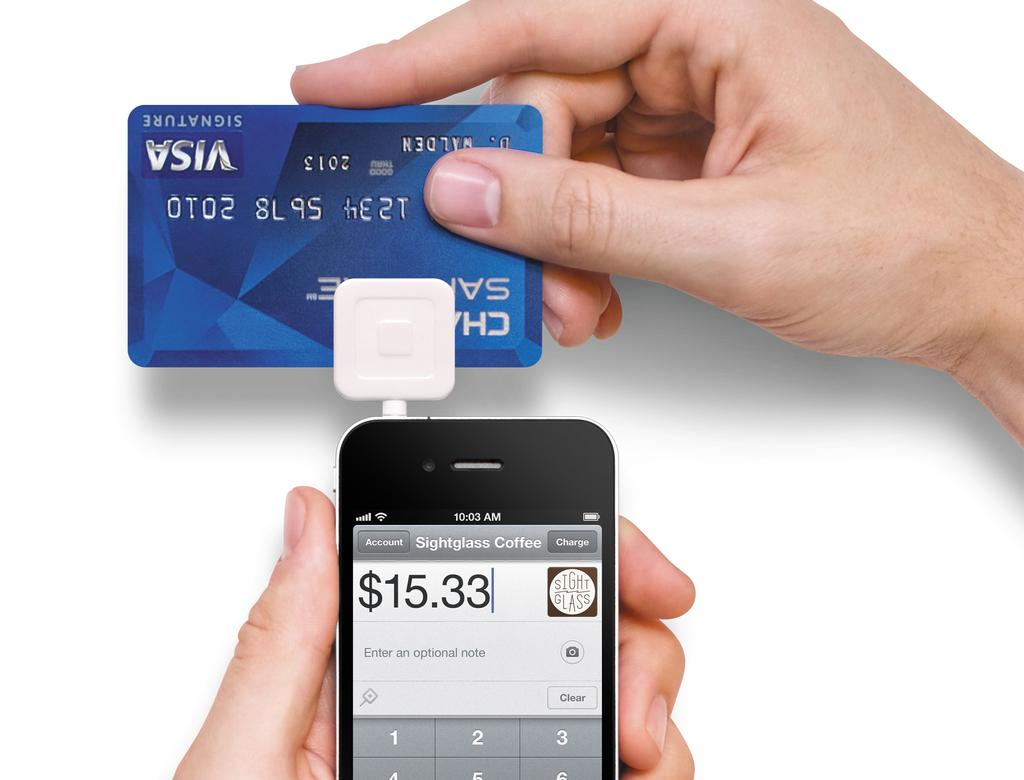<image>
Describe the image concisely. A man is swiping a Visa card to make a $15.33 payment. 